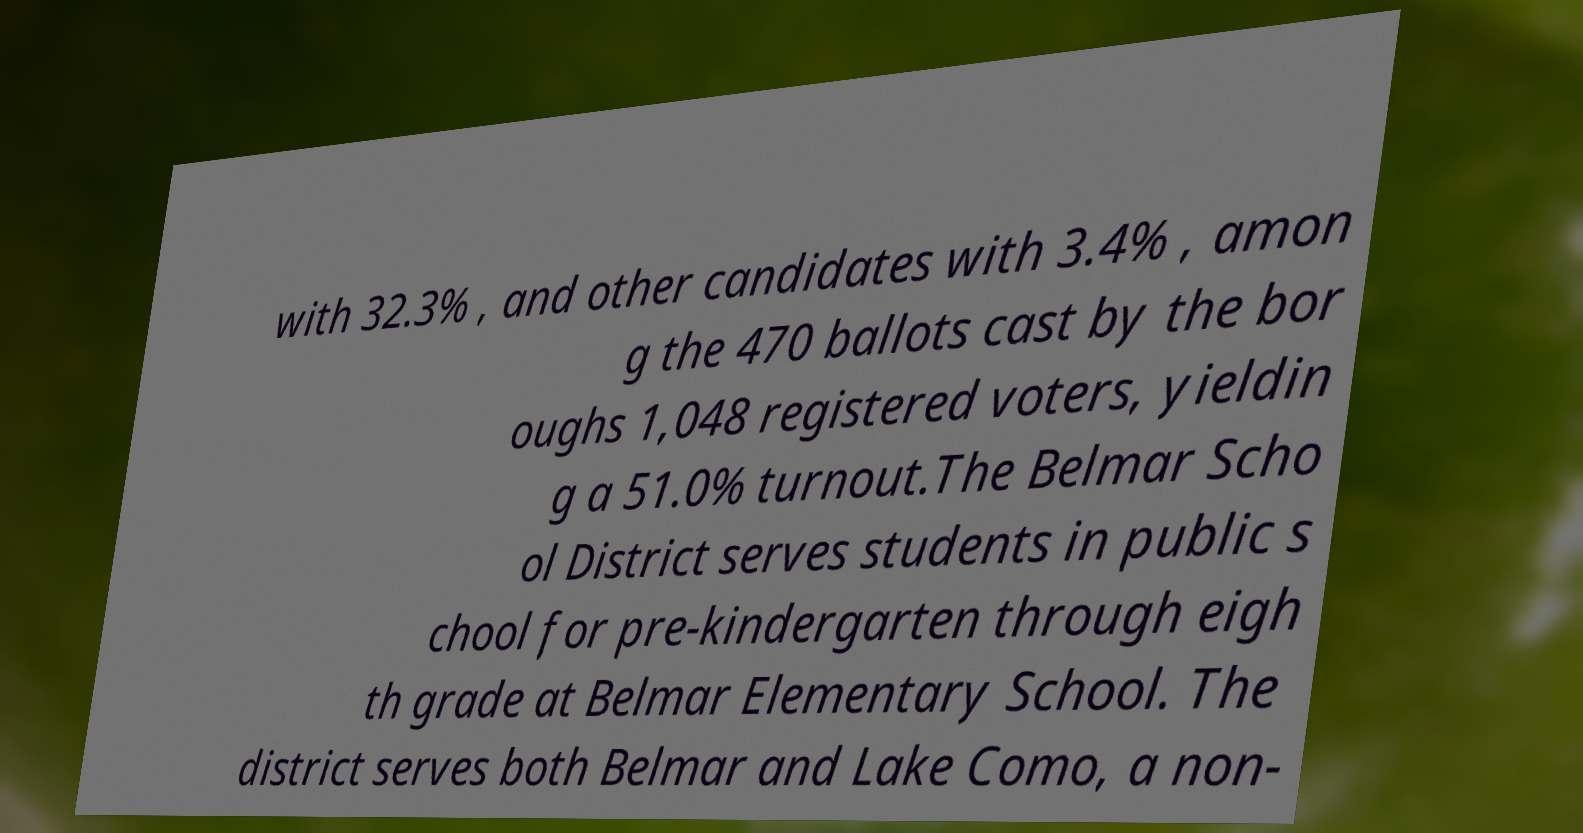Could you extract and type out the text from this image? with 32.3% , and other candidates with 3.4% , amon g the 470 ballots cast by the bor oughs 1,048 registered voters, yieldin g a 51.0% turnout.The Belmar Scho ol District serves students in public s chool for pre-kindergarten through eigh th grade at Belmar Elementary School. The district serves both Belmar and Lake Como, a non- 